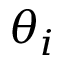<formula> <loc_0><loc_0><loc_500><loc_500>\theta _ { i }</formula> 